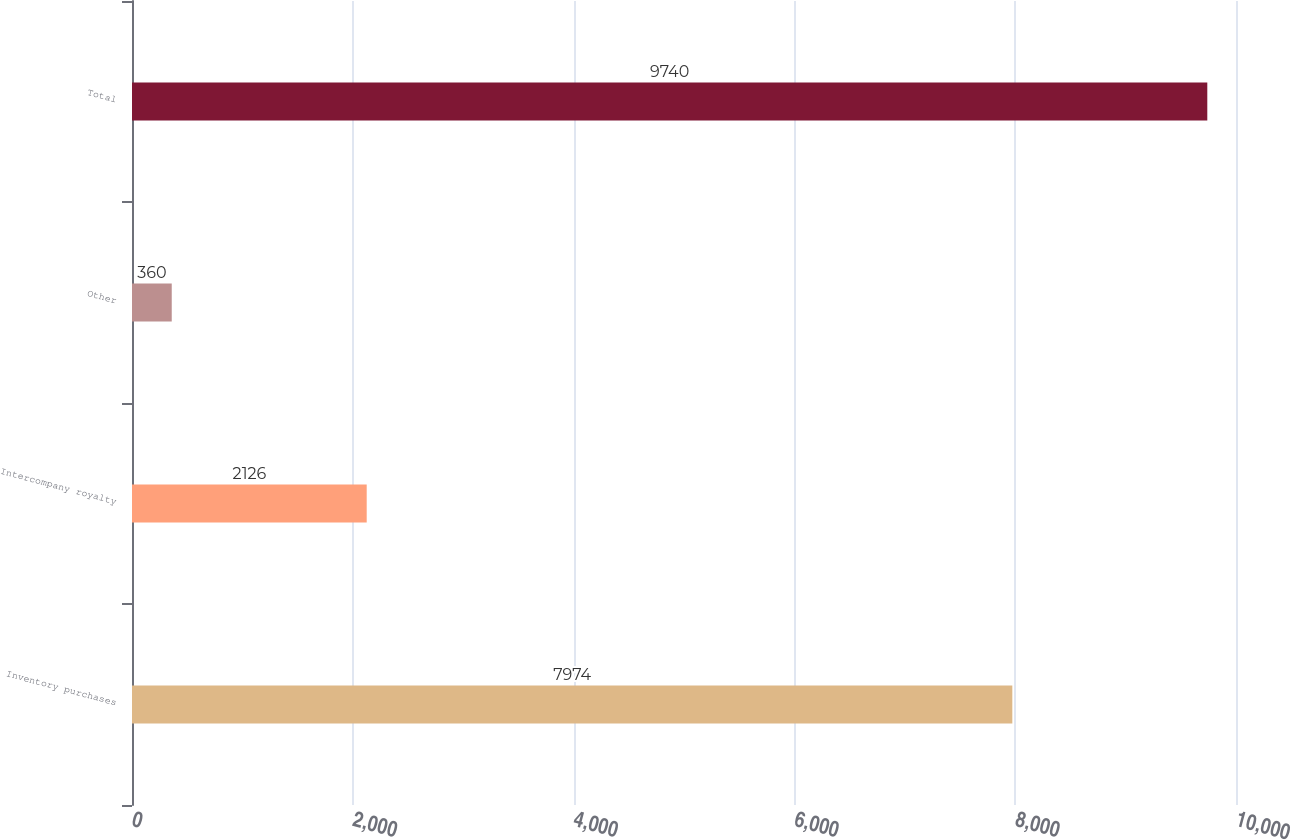Convert chart to OTSL. <chart><loc_0><loc_0><loc_500><loc_500><bar_chart><fcel>Inventory purchases<fcel>Intercompany royalty<fcel>Other<fcel>Total<nl><fcel>7974<fcel>2126<fcel>360<fcel>9740<nl></chart> 